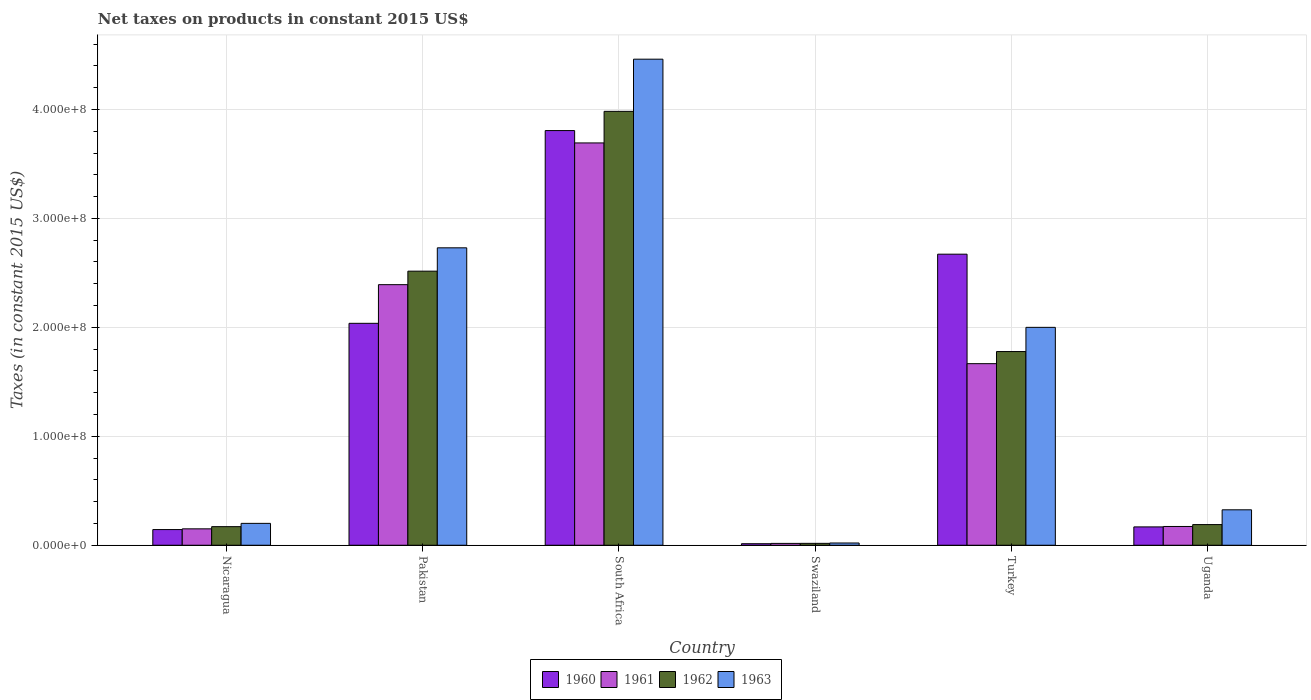How many different coloured bars are there?
Your answer should be compact. 4. How many groups of bars are there?
Your response must be concise. 6. Are the number of bars per tick equal to the number of legend labels?
Give a very brief answer. Yes. Are the number of bars on each tick of the X-axis equal?
Your response must be concise. Yes. What is the label of the 1st group of bars from the left?
Keep it short and to the point. Nicaragua. What is the net taxes on products in 1962 in Swaziland?
Make the answer very short. 1.73e+06. Across all countries, what is the maximum net taxes on products in 1960?
Offer a very short reply. 3.81e+08. Across all countries, what is the minimum net taxes on products in 1961?
Offer a very short reply. 1.69e+06. In which country was the net taxes on products in 1962 maximum?
Give a very brief answer. South Africa. In which country was the net taxes on products in 1962 minimum?
Offer a very short reply. Swaziland. What is the total net taxes on products in 1962 in the graph?
Make the answer very short. 8.65e+08. What is the difference between the net taxes on products in 1961 in Swaziland and that in Uganda?
Your answer should be very brief. -1.55e+07. What is the difference between the net taxes on products in 1960 in Swaziland and the net taxes on products in 1961 in Uganda?
Offer a terse response. -1.58e+07. What is the average net taxes on products in 1960 per country?
Your answer should be compact. 1.47e+08. What is the difference between the net taxes on products of/in 1961 and net taxes on products of/in 1963 in Uganda?
Make the answer very short. -1.53e+07. In how many countries, is the net taxes on products in 1963 greater than 40000000 US$?
Provide a succinct answer. 3. What is the ratio of the net taxes on products in 1962 in South Africa to that in Turkey?
Provide a succinct answer. 2.24. Is the net taxes on products in 1963 in South Africa less than that in Uganda?
Give a very brief answer. No. What is the difference between the highest and the second highest net taxes on products in 1962?
Offer a terse response. 2.20e+08. What is the difference between the highest and the lowest net taxes on products in 1963?
Provide a short and direct response. 4.44e+08. Is the sum of the net taxes on products in 1963 in Turkey and Uganda greater than the maximum net taxes on products in 1962 across all countries?
Offer a terse response. No. What does the 2nd bar from the left in Turkey represents?
Keep it short and to the point. 1961. What is the difference between two consecutive major ticks on the Y-axis?
Your answer should be very brief. 1.00e+08. Does the graph contain any zero values?
Ensure brevity in your answer.  No. Where does the legend appear in the graph?
Your response must be concise. Bottom center. How many legend labels are there?
Provide a short and direct response. 4. How are the legend labels stacked?
Keep it short and to the point. Horizontal. What is the title of the graph?
Your answer should be compact. Net taxes on products in constant 2015 US$. What is the label or title of the X-axis?
Offer a very short reply. Country. What is the label or title of the Y-axis?
Give a very brief answer. Taxes (in constant 2015 US$). What is the Taxes (in constant 2015 US$) of 1960 in Nicaragua?
Ensure brevity in your answer.  1.44e+07. What is the Taxes (in constant 2015 US$) of 1961 in Nicaragua?
Offer a very short reply. 1.51e+07. What is the Taxes (in constant 2015 US$) of 1962 in Nicaragua?
Make the answer very short. 1.71e+07. What is the Taxes (in constant 2015 US$) of 1963 in Nicaragua?
Provide a succinct answer. 2.01e+07. What is the Taxes (in constant 2015 US$) of 1960 in Pakistan?
Provide a short and direct response. 2.04e+08. What is the Taxes (in constant 2015 US$) of 1961 in Pakistan?
Ensure brevity in your answer.  2.39e+08. What is the Taxes (in constant 2015 US$) of 1962 in Pakistan?
Ensure brevity in your answer.  2.52e+08. What is the Taxes (in constant 2015 US$) in 1963 in Pakistan?
Provide a succinct answer. 2.73e+08. What is the Taxes (in constant 2015 US$) of 1960 in South Africa?
Offer a very short reply. 3.81e+08. What is the Taxes (in constant 2015 US$) of 1961 in South Africa?
Offer a terse response. 3.69e+08. What is the Taxes (in constant 2015 US$) in 1962 in South Africa?
Keep it short and to the point. 3.98e+08. What is the Taxes (in constant 2015 US$) of 1963 in South Africa?
Your answer should be very brief. 4.46e+08. What is the Taxes (in constant 2015 US$) of 1960 in Swaziland?
Your answer should be very brief. 1.40e+06. What is the Taxes (in constant 2015 US$) in 1961 in Swaziland?
Ensure brevity in your answer.  1.69e+06. What is the Taxes (in constant 2015 US$) in 1962 in Swaziland?
Your answer should be very brief. 1.73e+06. What is the Taxes (in constant 2015 US$) in 1963 in Swaziland?
Your answer should be compact. 2.06e+06. What is the Taxes (in constant 2015 US$) in 1960 in Turkey?
Keep it short and to the point. 2.67e+08. What is the Taxes (in constant 2015 US$) of 1961 in Turkey?
Offer a terse response. 1.67e+08. What is the Taxes (in constant 2015 US$) of 1962 in Turkey?
Make the answer very short. 1.78e+08. What is the Taxes (in constant 2015 US$) of 1960 in Uganda?
Your answer should be very brief. 1.68e+07. What is the Taxes (in constant 2015 US$) of 1961 in Uganda?
Offer a terse response. 1.72e+07. What is the Taxes (in constant 2015 US$) in 1962 in Uganda?
Your answer should be compact. 1.90e+07. What is the Taxes (in constant 2015 US$) of 1963 in Uganda?
Make the answer very short. 3.25e+07. Across all countries, what is the maximum Taxes (in constant 2015 US$) in 1960?
Your answer should be very brief. 3.81e+08. Across all countries, what is the maximum Taxes (in constant 2015 US$) in 1961?
Keep it short and to the point. 3.69e+08. Across all countries, what is the maximum Taxes (in constant 2015 US$) in 1962?
Keep it short and to the point. 3.98e+08. Across all countries, what is the maximum Taxes (in constant 2015 US$) of 1963?
Provide a short and direct response. 4.46e+08. Across all countries, what is the minimum Taxes (in constant 2015 US$) in 1960?
Provide a succinct answer. 1.40e+06. Across all countries, what is the minimum Taxes (in constant 2015 US$) in 1961?
Provide a short and direct response. 1.69e+06. Across all countries, what is the minimum Taxes (in constant 2015 US$) in 1962?
Provide a succinct answer. 1.73e+06. Across all countries, what is the minimum Taxes (in constant 2015 US$) of 1963?
Keep it short and to the point. 2.06e+06. What is the total Taxes (in constant 2015 US$) of 1960 in the graph?
Offer a very short reply. 8.84e+08. What is the total Taxes (in constant 2015 US$) of 1961 in the graph?
Your answer should be very brief. 8.09e+08. What is the total Taxes (in constant 2015 US$) in 1962 in the graph?
Offer a very short reply. 8.65e+08. What is the total Taxes (in constant 2015 US$) of 1963 in the graph?
Offer a terse response. 9.74e+08. What is the difference between the Taxes (in constant 2015 US$) of 1960 in Nicaragua and that in Pakistan?
Your answer should be compact. -1.89e+08. What is the difference between the Taxes (in constant 2015 US$) in 1961 in Nicaragua and that in Pakistan?
Keep it short and to the point. -2.24e+08. What is the difference between the Taxes (in constant 2015 US$) of 1962 in Nicaragua and that in Pakistan?
Provide a succinct answer. -2.35e+08. What is the difference between the Taxes (in constant 2015 US$) in 1963 in Nicaragua and that in Pakistan?
Provide a succinct answer. -2.53e+08. What is the difference between the Taxes (in constant 2015 US$) of 1960 in Nicaragua and that in South Africa?
Provide a short and direct response. -3.66e+08. What is the difference between the Taxes (in constant 2015 US$) in 1961 in Nicaragua and that in South Africa?
Keep it short and to the point. -3.54e+08. What is the difference between the Taxes (in constant 2015 US$) in 1962 in Nicaragua and that in South Africa?
Your answer should be very brief. -3.81e+08. What is the difference between the Taxes (in constant 2015 US$) in 1963 in Nicaragua and that in South Africa?
Keep it short and to the point. -4.26e+08. What is the difference between the Taxes (in constant 2015 US$) in 1960 in Nicaragua and that in Swaziland?
Make the answer very short. 1.30e+07. What is the difference between the Taxes (in constant 2015 US$) of 1961 in Nicaragua and that in Swaziland?
Offer a terse response. 1.34e+07. What is the difference between the Taxes (in constant 2015 US$) in 1962 in Nicaragua and that in Swaziland?
Provide a succinct answer. 1.53e+07. What is the difference between the Taxes (in constant 2015 US$) of 1963 in Nicaragua and that in Swaziland?
Give a very brief answer. 1.80e+07. What is the difference between the Taxes (in constant 2015 US$) of 1960 in Nicaragua and that in Turkey?
Offer a terse response. -2.53e+08. What is the difference between the Taxes (in constant 2015 US$) of 1961 in Nicaragua and that in Turkey?
Your response must be concise. -1.52e+08. What is the difference between the Taxes (in constant 2015 US$) of 1962 in Nicaragua and that in Turkey?
Your response must be concise. -1.61e+08. What is the difference between the Taxes (in constant 2015 US$) of 1963 in Nicaragua and that in Turkey?
Keep it short and to the point. -1.80e+08. What is the difference between the Taxes (in constant 2015 US$) of 1960 in Nicaragua and that in Uganda?
Make the answer very short. -2.45e+06. What is the difference between the Taxes (in constant 2015 US$) of 1961 in Nicaragua and that in Uganda?
Make the answer very short. -2.17e+06. What is the difference between the Taxes (in constant 2015 US$) of 1962 in Nicaragua and that in Uganda?
Your answer should be very brief. -1.89e+06. What is the difference between the Taxes (in constant 2015 US$) in 1963 in Nicaragua and that in Uganda?
Provide a short and direct response. -1.24e+07. What is the difference between the Taxes (in constant 2015 US$) of 1960 in Pakistan and that in South Africa?
Your response must be concise. -1.77e+08. What is the difference between the Taxes (in constant 2015 US$) of 1961 in Pakistan and that in South Africa?
Ensure brevity in your answer.  -1.30e+08. What is the difference between the Taxes (in constant 2015 US$) of 1962 in Pakistan and that in South Africa?
Your answer should be very brief. -1.47e+08. What is the difference between the Taxes (in constant 2015 US$) in 1963 in Pakistan and that in South Africa?
Offer a terse response. -1.73e+08. What is the difference between the Taxes (in constant 2015 US$) of 1960 in Pakistan and that in Swaziland?
Your answer should be compact. 2.02e+08. What is the difference between the Taxes (in constant 2015 US$) of 1961 in Pakistan and that in Swaziland?
Make the answer very short. 2.37e+08. What is the difference between the Taxes (in constant 2015 US$) in 1962 in Pakistan and that in Swaziland?
Your response must be concise. 2.50e+08. What is the difference between the Taxes (in constant 2015 US$) in 1963 in Pakistan and that in Swaziland?
Provide a short and direct response. 2.71e+08. What is the difference between the Taxes (in constant 2015 US$) in 1960 in Pakistan and that in Turkey?
Provide a short and direct response. -6.35e+07. What is the difference between the Taxes (in constant 2015 US$) in 1961 in Pakistan and that in Turkey?
Keep it short and to the point. 7.25e+07. What is the difference between the Taxes (in constant 2015 US$) in 1962 in Pakistan and that in Turkey?
Your answer should be very brief. 7.38e+07. What is the difference between the Taxes (in constant 2015 US$) in 1963 in Pakistan and that in Turkey?
Your response must be concise. 7.30e+07. What is the difference between the Taxes (in constant 2015 US$) in 1960 in Pakistan and that in Uganda?
Make the answer very short. 1.87e+08. What is the difference between the Taxes (in constant 2015 US$) of 1961 in Pakistan and that in Uganda?
Ensure brevity in your answer.  2.22e+08. What is the difference between the Taxes (in constant 2015 US$) of 1962 in Pakistan and that in Uganda?
Offer a terse response. 2.33e+08. What is the difference between the Taxes (in constant 2015 US$) in 1963 in Pakistan and that in Uganda?
Your answer should be very brief. 2.40e+08. What is the difference between the Taxes (in constant 2015 US$) of 1960 in South Africa and that in Swaziland?
Make the answer very short. 3.79e+08. What is the difference between the Taxes (in constant 2015 US$) in 1961 in South Africa and that in Swaziland?
Give a very brief answer. 3.68e+08. What is the difference between the Taxes (in constant 2015 US$) in 1962 in South Africa and that in Swaziland?
Provide a succinct answer. 3.97e+08. What is the difference between the Taxes (in constant 2015 US$) of 1963 in South Africa and that in Swaziland?
Provide a succinct answer. 4.44e+08. What is the difference between the Taxes (in constant 2015 US$) in 1960 in South Africa and that in Turkey?
Keep it short and to the point. 1.13e+08. What is the difference between the Taxes (in constant 2015 US$) of 1961 in South Africa and that in Turkey?
Provide a short and direct response. 2.03e+08. What is the difference between the Taxes (in constant 2015 US$) of 1962 in South Africa and that in Turkey?
Your response must be concise. 2.20e+08. What is the difference between the Taxes (in constant 2015 US$) in 1963 in South Africa and that in Turkey?
Keep it short and to the point. 2.46e+08. What is the difference between the Taxes (in constant 2015 US$) in 1960 in South Africa and that in Uganda?
Make the answer very short. 3.64e+08. What is the difference between the Taxes (in constant 2015 US$) in 1961 in South Africa and that in Uganda?
Offer a very short reply. 3.52e+08. What is the difference between the Taxes (in constant 2015 US$) in 1962 in South Africa and that in Uganda?
Give a very brief answer. 3.79e+08. What is the difference between the Taxes (in constant 2015 US$) of 1963 in South Africa and that in Uganda?
Provide a short and direct response. 4.14e+08. What is the difference between the Taxes (in constant 2015 US$) of 1960 in Swaziland and that in Turkey?
Your answer should be compact. -2.66e+08. What is the difference between the Taxes (in constant 2015 US$) of 1961 in Swaziland and that in Turkey?
Your response must be concise. -1.65e+08. What is the difference between the Taxes (in constant 2015 US$) in 1962 in Swaziland and that in Turkey?
Offer a very short reply. -1.76e+08. What is the difference between the Taxes (in constant 2015 US$) of 1963 in Swaziland and that in Turkey?
Make the answer very short. -1.98e+08. What is the difference between the Taxes (in constant 2015 US$) of 1960 in Swaziland and that in Uganda?
Make the answer very short. -1.54e+07. What is the difference between the Taxes (in constant 2015 US$) in 1961 in Swaziland and that in Uganda?
Offer a very short reply. -1.55e+07. What is the difference between the Taxes (in constant 2015 US$) in 1962 in Swaziland and that in Uganda?
Keep it short and to the point. -1.72e+07. What is the difference between the Taxes (in constant 2015 US$) of 1963 in Swaziland and that in Uganda?
Your response must be concise. -3.05e+07. What is the difference between the Taxes (in constant 2015 US$) in 1960 in Turkey and that in Uganda?
Keep it short and to the point. 2.50e+08. What is the difference between the Taxes (in constant 2015 US$) of 1961 in Turkey and that in Uganda?
Offer a terse response. 1.49e+08. What is the difference between the Taxes (in constant 2015 US$) in 1962 in Turkey and that in Uganda?
Offer a terse response. 1.59e+08. What is the difference between the Taxes (in constant 2015 US$) in 1963 in Turkey and that in Uganda?
Provide a succinct answer. 1.67e+08. What is the difference between the Taxes (in constant 2015 US$) in 1960 in Nicaragua and the Taxes (in constant 2015 US$) in 1961 in Pakistan?
Keep it short and to the point. -2.25e+08. What is the difference between the Taxes (in constant 2015 US$) in 1960 in Nicaragua and the Taxes (in constant 2015 US$) in 1962 in Pakistan?
Make the answer very short. -2.37e+08. What is the difference between the Taxes (in constant 2015 US$) in 1960 in Nicaragua and the Taxes (in constant 2015 US$) in 1963 in Pakistan?
Your response must be concise. -2.59e+08. What is the difference between the Taxes (in constant 2015 US$) of 1961 in Nicaragua and the Taxes (in constant 2015 US$) of 1962 in Pakistan?
Keep it short and to the point. -2.37e+08. What is the difference between the Taxes (in constant 2015 US$) of 1961 in Nicaragua and the Taxes (in constant 2015 US$) of 1963 in Pakistan?
Your response must be concise. -2.58e+08. What is the difference between the Taxes (in constant 2015 US$) in 1962 in Nicaragua and the Taxes (in constant 2015 US$) in 1963 in Pakistan?
Ensure brevity in your answer.  -2.56e+08. What is the difference between the Taxes (in constant 2015 US$) in 1960 in Nicaragua and the Taxes (in constant 2015 US$) in 1961 in South Africa?
Make the answer very short. -3.55e+08. What is the difference between the Taxes (in constant 2015 US$) in 1960 in Nicaragua and the Taxes (in constant 2015 US$) in 1962 in South Africa?
Make the answer very short. -3.84e+08. What is the difference between the Taxes (in constant 2015 US$) of 1960 in Nicaragua and the Taxes (in constant 2015 US$) of 1963 in South Africa?
Provide a succinct answer. -4.32e+08. What is the difference between the Taxes (in constant 2015 US$) in 1961 in Nicaragua and the Taxes (in constant 2015 US$) in 1962 in South Africa?
Ensure brevity in your answer.  -3.83e+08. What is the difference between the Taxes (in constant 2015 US$) of 1961 in Nicaragua and the Taxes (in constant 2015 US$) of 1963 in South Africa?
Offer a terse response. -4.31e+08. What is the difference between the Taxes (in constant 2015 US$) in 1962 in Nicaragua and the Taxes (in constant 2015 US$) in 1963 in South Africa?
Make the answer very short. -4.29e+08. What is the difference between the Taxes (in constant 2015 US$) in 1960 in Nicaragua and the Taxes (in constant 2015 US$) in 1961 in Swaziland?
Offer a terse response. 1.27e+07. What is the difference between the Taxes (in constant 2015 US$) in 1960 in Nicaragua and the Taxes (in constant 2015 US$) in 1962 in Swaziland?
Provide a succinct answer. 1.27e+07. What is the difference between the Taxes (in constant 2015 US$) in 1960 in Nicaragua and the Taxes (in constant 2015 US$) in 1963 in Swaziland?
Your answer should be very brief. 1.23e+07. What is the difference between the Taxes (in constant 2015 US$) in 1961 in Nicaragua and the Taxes (in constant 2015 US$) in 1962 in Swaziland?
Provide a short and direct response. 1.33e+07. What is the difference between the Taxes (in constant 2015 US$) of 1961 in Nicaragua and the Taxes (in constant 2015 US$) of 1963 in Swaziland?
Offer a very short reply. 1.30e+07. What is the difference between the Taxes (in constant 2015 US$) of 1962 in Nicaragua and the Taxes (in constant 2015 US$) of 1963 in Swaziland?
Offer a very short reply. 1.50e+07. What is the difference between the Taxes (in constant 2015 US$) in 1960 in Nicaragua and the Taxes (in constant 2015 US$) in 1961 in Turkey?
Offer a terse response. -1.52e+08. What is the difference between the Taxes (in constant 2015 US$) of 1960 in Nicaragua and the Taxes (in constant 2015 US$) of 1962 in Turkey?
Keep it short and to the point. -1.63e+08. What is the difference between the Taxes (in constant 2015 US$) of 1960 in Nicaragua and the Taxes (in constant 2015 US$) of 1963 in Turkey?
Keep it short and to the point. -1.86e+08. What is the difference between the Taxes (in constant 2015 US$) in 1961 in Nicaragua and the Taxes (in constant 2015 US$) in 1962 in Turkey?
Give a very brief answer. -1.63e+08. What is the difference between the Taxes (in constant 2015 US$) in 1961 in Nicaragua and the Taxes (in constant 2015 US$) in 1963 in Turkey?
Your response must be concise. -1.85e+08. What is the difference between the Taxes (in constant 2015 US$) of 1962 in Nicaragua and the Taxes (in constant 2015 US$) of 1963 in Turkey?
Your answer should be compact. -1.83e+08. What is the difference between the Taxes (in constant 2015 US$) of 1960 in Nicaragua and the Taxes (in constant 2015 US$) of 1961 in Uganda?
Your response must be concise. -2.84e+06. What is the difference between the Taxes (in constant 2015 US$) in 1960 in Nicaragua and the Taxes (in constant 2015 US$) in 1962 in Uganda?
Ensure brevity in your answer.  -4.57e+06. What is the difference between the Taxes (in constant 2015 US$) of 1960 in Nicaragua and the Taxes (in constant 2015 US$) of 1963 in Uganda?
Ensure brevity in your answer.  -1.81e+07. What is the difference between the Taxes (in constant 2015 US$) in 1961 in Nicaragua and the Taxes (in constant 2015 US$) in 1962 in Uganda?
Make the answer very short. -3.90e+06. What is the difference between the Taxes (in constant 2015 US$) of 1961 in Nicaragua and the Taxes (in constant 2015 US$) of 1963 in Uganda?
Ensure brevity in your answer.  -1.75e+07. What is the difference between the Taxes (in constant 2015 US$) in 1962 in Nicaragua and the Taxes (in constant 2015 US$) in 1963 in Uganda?
Your answer should be compact. -1.55e+07. What is the difference between the Taxes (in constant 2015 US$) in 1960 in Pakistan and the Taxes (in constant 2015 US$) in 1961 in South Africa?
Provide a short and direct response. -1.66e+08. What is the difference between the Taxes (in constant 2015 US$) of 1960 in Pakistan and the Taxes (in constant 2015 US$) of 1962 in South Africa?
Provide a short and direct response. -1.95e+08. What is the difference between the Taxes (in constant 2015 US$) in 1960 in Pakistan and the Taxes (in constant 2015 US$) in 1963 in South Africa?
Give a very brief answer. -2.42e+08. What is the difference between the Taxes (in constant 2015 US$) in 1961 in Pakistan and the Taxes (in constant 2015 US$) in 1962 in South Africa?
Ensure brevity in your answer.  -1.59e+08. What is the difference between the Taxes (in constant 2015 US$) in 1961 in Pakistan and the Taxes (in constant 2015 US$) in 1963 in South Africa?
Provide a succinct answer. -2.07e+08. What is the difference between the Taxes (in constant 2015 US$) of 1962 in Pakistan and the Taxes (in constant 2015 US$) of 1963 in South Africa?
Your answer should be compact. -1.95e+08. What is the difference between the Taxes (in constant 2015 US$) in 1960 in Pakistan and the Taxes (in constant 2015 US$) in 1961 in Swaziland?
Make the answer very short. 2.02e+08. What is the difference between the Taxes (in constant 2015 US$) of 1960 in Pakistan and the Taxes (in constant 2015 US$) of 1962 in Swaziland?
Offer a very short reply. 2.02e+08. What is the difference between the Taxes (in constant 2015 US$) in 1960 in Pakistan and the Taxes (in constant 2015 US$) in 1963 in Swaziland?
Make the answer very short. 2.02e+08. What is the difference between the Taxes (in constant 2015 US$) in 1961 in Pakistan and the Taxes (in constant 2015 US$) in 1962 in Swaziland?
Make the answer very short. 2.37e+08. What is the difference between the Taxes (in constant 2015 US$) of 1961 in Pakistan and the Taxes (in constant 2015 US$) of 1963 in Swaziland?
Ensure brevity in your answer.  2.37e+08. What is the difference between the Taxes (in constant 2015 US$) in 1962 in Pakistan and the Taxes (in constant 2015 US$) in 1963 in Swaziland?
Ensure brevity in your answer.  2.50e+08. What is the difference between the Taxes (in constant 2015 US$) in 1960 in Pakistan and the Taxes (in constant 2015 US$) in 1961 in Turkey?
Ensure brevity in your answer.  3.70e+07. What is the difference between the Taxes (in constant 2015 US$) in 1960 in Pakistan and the Taxes (in constant 2015 US$) in 1962 in Turkey?
Provide a succinct answer. 2.59e+07. What is the difference between the Taxes (in constant 2015 US$) of 1960 in Pakistan and the Taxes (in constant 2015 US$) of 1963 in Turkey?
Give a very brief answer. 3.70e+06. What is the difference between the Taxes (in constant 2015 US$) of 1961 in Pakistan and the Taxes (in constant 2015 US$) of 1962 in Turkey?
Your response must be concise. 6.14e+07. What is the difference between the Taxes (in constant 2015 US$) of 1961 in Pakistan and the Taxes (in constant 2015 US$) of 1963 in Turkey?
Your answer should be compact. 3.92e+07. What is the difference between the Taxes (in constant 2015 US$) in 1962 in Pakistan and the Taxes (in constant 2015 US$) in 1963 in Turkey?
Your response must be concise. 5.16e+07. What is the difference between the Taxes (in constant 2015 US$) of 1960 in Pakistan and the Taxes (in constant 2015 US$) of 1961 in Uganda?
Provide a succinct answer. 1.86e+08. What is the difference between the Taxes (in constant 2015 US$) in 1960 in Pakistan and the Taxes (in constant 2015 US$) in 1962 in Uganda?
Keep it short and to the point. 1.85e+08. What is the difference between the Taxes (in constant 2015 US$) in 1960 in Pakistan and the Taxes (in constant 2015 US$) in 1963 in Uganda?
Make the answer very short. 1.71e+08. What is the difference between the Taxes (in constant 2015 US$) in 1961 in Pakistan and the Taxes (in constant 2015 US$) in 1962 in Uganda?
Provide a succinct answer. 2.20e+08. What is the difference between the Taxes (in constant 2015 US$) in 1961 in Pakistan and the Taxes (in constant 2015 US$) in 1963 in Uganda?
Offer a terse response. 2.07e+08. What is the difference between the Taxes (in constant 2015 US$) of 1962 in Pakistan and the Taxes (in constant 2015 US$) of 1963 in Uganda?
Keep it short and to the point. 2.19e+08. What is the difference between the Taxes (in constant 2015 US$) in 1960 in South Africa and the Taxes (in constant 2015 US$) in 1961 in Swaziland?
Ensure brevity in your answer.  3.79e+08. What is the difference between the Taxes (in constant 2015 US$) in 1960 in South Africa and the Taxes (in constant 2015 US$) in 1962 in Swaziland?
Keep it short and to the point. 3.79e+08. What is the difference between the Taxes (in constant 2015 US$) in 1960 in South Africa and the Taxes (in constant 2015 US$) in 1963 in Swaziland?
Ensure brevity in your answer.  3.79e+08. What is the difference between the Taxes (in constant 2015 US$) in 1961 in South Africa and the Taxes (in constant 2015 US$) in 1962 in Swaziland?
Keep it short and to the point. 3.68e+08. What is the difference between the Taxes (in constant 2015 US$) of 1961 in South Africa and the Taxes (in constant 2015 US$) of 1963 in Swaziland?
Offer a very short reply. 3.67e+08. What is the difference between the Taxes (in constant 2015 US$) in 1962 in South Africa and the Taxes (in constant 2015 US$) in 1963 in Swaziland?
Provide a succinct answer. 3.96e+08. What is the difference between the Taxes (in constant 2015 US$) in 1960 in South Africa and the Taxes (in constant 2015 US$) in 1961 in Turkey?
Offer a terse response. 2.14e+08. What is the difference between the Taxes (in constant 2015 US$) of 1960 in South Africa and the Taxes (in constant 2015 US$) of 1962 in Turkey?
Ensure brevity in your answer.  2.03e+08. What is the difference between the Taxes (in constant 2015 US$) in 1960 in South Africa and the Taxes (in constant 2015 US$) in 1963 in Turkey?
Give a very brief answer. 1.81e+08. What is the difference between the Taxes (in constant 2015 US$) of 1961 in South Africa and the Taxes (in constant 2015 US$) of 1962 in Turkey?
Keep it short and to the point. 1.91e+08. What is the difference between the Taxes (in constant 2015 US$) of 1961 in South Africa and the Taxes (in constant 2015 US$) of 1963 in Turkey?
Offer a very short reply. 1.69e+08. What is the difference between the Taxes (in constant 2015 US$) in 1962 in South Africa and the Taxes (in constant 2015 US$) in 1963 in Turkey?
Offer a very short reply. 1.98e+08. What is the difference between the Taxes (in constant 2015 US$) in 1960 in South Africa and the Taxes (in constant 2015 US$) in 1961 in Uganda?
Your answer should be compact. 3.63e+08. What is the difference between the Taxes (in constant 2015 US$) of 1960 in South Africa and the Taxes (in constant 2015 US$) of 1962 in Uganda?
Give a very brief answer. 3.62e+08. What is the difference between the Taxes (in constant 2015 US$) of 1960 in South Africa and the Taxes (in constant 2015 US$) of 1963 in Uganda?
Make the answer very short. 3.48e+08. What is the difference between the Taxes (in constant 2015 US$) of 1961 in South Africa and the Taxes (in constant 2015 US$) of 1962 in Uganda?
Your response must be concise. 3.50e+08. What is the difference between the Taxes (in constant 2015 US$) in 1961 in South Africa and the Taxes (in constant 2015 US$) in 1963 in Uganda?
Provide a short and direct response. 3.37e+08. What is the difference between the Taxes (in constant 2015 US$) in 1962 in South Africa and the Taxes (in constant 2015 US$) in 1963 in Uganda?
Make the answer very short. 3.66e+08. What is the difference between the Taxes (in constant 2015 US$) in 1960 in Swaziland and the Taxes (in constant 2015 US$) in 1961 in Turkey?
Your answer should be compact. -1.65e+08. What is the difference between the Taxes (in constant 2015 US$) of 1960 in Swaziland and the Taxes (in constant 2015 US$) of 1962 in Turkey?
Give a very brief answer. -1.76e+08. What is the difference between the Taxes (in constant 2015 US$) of 1960 in Swaziland and the Taxes (in constant 2015 US$) of 1963 in Turkey?
Provide a short and direct response. -1.99e+08. What is the difference between the Taxes (in constant 2015 US$) in 1961 in Swaziland and the Taxes (in constant 2015 US$) in 1962 in Turkey?
Make the answer very short. -1.76e+08. What is the difference between the Taxes (in constant 2015 US$) in 1961 in Swaziland and the Taxes (in constant 2015 US$) in 1963 in Turkey?
Offer a terse response. -1.98e+08. What is the difference between the Taxes (in constant 2015 US$) in 1962 in Swaziland and the Taxes (in constant 2015 US$) in 1963 in Turkey?
Keep it short and to the point. -1.98e+08. What is the difference between the Taxes (in constant 2015 US$) of 1960 in Swaziland and the Taxes (in constant 2015 US$) of 1961 in Uganda?
Ensure brevity in your answer.  -1.58e+07. What is the difference between the Taxes (in constant 2015 US$) of 1960 in Swaziland and the Taxes (in constant 2015 US$) of 1962 in Uganda?
Make the answer very short. -1.76e+07. What is the difference between the Taxes (in constant 2015 US$) of 1960 in Swaziland and the Taxes (in constant 2015 US$) of 1963 in Uganda?
Give a very brief answer. -3.11e+07. What is the difference between the Taxes (in constant 2015 US$) of 1961 in Swaziland and the Taxes (in constant 2015 US$) of 1962 in Uganda?
Ensure brevity in your answer.  -1.73e+07. What is the difference between the Taxes (in constant 2015 US$) of 1961 in Swaziland and the Taxes (in constant 2015 US$) of 1963 in Uganda?
Make the answer very short. -3.08e+07. What is the difference between the Taxes (in constant 2015 US$) in 1962 in Swaziland and the Taxes (in constant 2015 US$) in 1963 in Uganda?
Your response must be concise. -3.08e+07. What is the difference between the Taxes (in constant 2015 US$) of 1960 in Turkey and the Taxes (in constant 2015 US$) of 1961 in Uganda?
Offer a very short reply. 2.50e+08. What is the difference between the Taxes (in constant 2015 US$) of 1960 in Turkey and the Taxes (in constant 2015 US$) of 1962 in Uganda?
Make the answer very short. 2.48e+08. What is the difference between the Taxes (in constant 2015 US$) of 1960 in Turkey and the Taxes (in constant 2015 US$) of 1963 in Uganda?
Give a very brief answer. 2.35e+08. What is the difference between the Taxes (in constant 2015 US$) in 1961 in Turkey and the Taxes (in constant 2015 US$) in 1962 in Uganda?
Your response must be concise. 1.48e+08. What is the difference between the Taxes (in constant 2015 US$) of 1961 in Turkey and the Taxes (in constant 2015 US$) of 1963 in Uganda?
Your answer should be compact. 1.34e+08. What is the difference between the Taxes (in constant 2015 US$) of 1962 in Turkey and the Taxes (in constant 2015 US$) of 1963 in Uganda?
Your answer should be compact. 1.45e+08. What is the average Taxes (in constant 2015 US$) in 1960 per country?
Your answer should be very brief. 1.47e+08. What is the average Taxes (in constant 2015 US$) of 1961 per country?
Offer a very short reply. 1.35e+08. What is the average Taxes (in constant 2015 US$) in 1962 per country?
Give a very brief answer. 1.44e+08. What is the average Taxes (in constant 2015 US$) of 1963 per country?
Keep it short and to the point. 1.62e+08. What is the difference between the Taxes (in constant 2015 US$) of 1960 and Taxes (in constant 2015 US$) of 1961 in Nicaragua?
Make the answer very short. -6.69e+05. What is the difference between the Taxes (in constant 2015 US$) of 1960 and Taxes (in constant 2015 US$) of 1962 in Nicaragua?
Your answer should be very brief. -2.68e+06. What is the difference between the Taxes (in constant 2015 US$) in 1960 and Taxes (in constant 2015 US$) in 1963 in Nicaragua?
Give a very brief answer. -5.69e+06. What is the difference between the Taxes (in constant 2015 US$) of 1961 and Taxes (in constant 2015 US$) of 1962 in Nicaragua?
Your response must be concise. -2.01e+06. What is the difference between the Taxes (in constant 2015 US$) in 1961 and Taxes (in constant 2015 US$) in 1963 in Nicaragua?
Make the answer very short. -5.02e+06. What is the difference between the Taxes (in constant 2015 US$) of 1962 and Taxes (in constant 2015 US$) of 1963 in Nicaragua?
Offer a terse response. -3.01e+06. What is the difference between the Taxes (in constant 2015 US$) of 1960 and Taxes (in constant 2015 US$) of 1961 in Pakistan?
Provide a succinct answer. -3.55e+07. What is the difference between the Taxes (in constant 2015 US$) in 1960 and Taxes (in constant 2015 US$) in 1962 in Pakistan?
Give a very brief answer. -4.79e+07. What is the difference between the Taxes (in constant 2015 US$) in 1960 and Taxes (in constant 2015 US$) in 1963 in Pakistan?
Ensure brevity in your answer.  -6.93e+07. What is the difference between the Taxes (in constant 2015 US$) of 1961 and Taxes (in constant 2015 US$) of 1962 in Pakistan?
Keep it short and to the point. -1.24e+07. What is the difference between the Taxes (in constant 2015 US$) in 1961 and Taxes (in constant 2015 US$) in 1963 in Pakistan?
Provide a succinct answer. -3.38e+07. What is the difference between the Taxes (in constant 2015 US$) in 1962 and Taxes (in constant 2015 US$) in 1963 in Pakistan?
Make the answer very short. -2.14e+07. What is the difference between the Taxes (in constant 2015 US$) of 1960 and Taxes (in constant 2015 US$) of 1961 in South Africa?
Your answer should be very brief. 1.13e+07. What is the difference between the Taxes (in constant 2015 US$) of 1960 and Taxes (in constant 2015 US$) of 1962 in South Africa?
Offer a terse response. -1.76e+07. What is the difference between the Taxes (in constant 2015 US$) of 1960 and Taxes (in constant 2015 US$) of 1963 in South Africa?
Your response must be concise. -6.55e+07. What is the difference between the Taxes (in constant 2015 US$) in 1961 and Taxes (in constant 2015 US$) in 1962 in South Africa?
Your answer should be very brief. -2.90e+07. What is the difference between the Taxes (in constant 2015 US$) in 1961 and Taxes (in constant 2015 US$) in 1963 in South Africa?
Make the answer very short. -7.69e+07. What is the difference between the Taxes (in constant 2015 US$) of 1962 and Taxes (in constant 2015 US$) of 1963 in South Africa?
Offer a terse response. -4.79e+07. What is the difference between the Taxes (in constant 2015 US$) of 1960 and Taxes (in constant 2015 US$) of 1961 in Swaziland?
Offer a very short reply. -2.89e+05. What is the difference between the Taxes (in constant 2015 US$) in 1960 and Taxes (in constant 2015 US$) in 1962 in Swaziland?
Offer a very short reply. -3.30e+05. What is the difference between the Taxes (in constant 2015 US$) of 1960 and Taxes (in constant 2015 US$) of 1963 in Swaziland?
Offer a very short reply. -6.61e+05. What is the difference between the Taxes (in constant 2015 US$) in 1961 and Taxes (in constant 2015 US$) in 1962 in Swaziland?
Provide a succinct answer. -4.13e+04. What is the difference between the Taxes (in constant 2015 US$) of 1961 and Taxes (in constant 2015 US$) of 1963 in Swaziland?
Your response must be concise. -3.72e+05. What is the difference between the Taxes (in constant 2015 US$) in 1962 and Taxes (in constant 2015 US$) in 1963 in Swaziland?
Make the answer very short. -3.30e+05. What is the difference between the Taxes (in constant 2015 US$) in 1960 and Taxes (in constant 2015 US$) in 1961 in Turkey?
Provide a succinct answer. 1.00e+08. What is the difference between the Taxes (in constant 2015 US$) in 1960 and Taxes (in constant 2015 US$) in 1962 in Turkey?
Give a very brief answer. 8.94e+07. What is the difference between the Taxes (in constant 2015 US$) of 1960 and Taxes (in constant 2015 US$) of 1963 in Turkey?
Keep it short and to the point. 6.72e+07. What is the difference between the Taxes (in constant 2015 US$) in 1961 and Taxes (in constant 2015 US$) in 1962 in Turkey?
Give a very brief answer. -1.11e+07. What is the difference between the Taxes (in constant 2015 US$) of 1961 and Taxes (in constant 2015 US$) of 1963 in Turkey?
Your answer should be compact. -3.33e+07. What is the difference between the Taxes (in constant 2015 US$) of 1962 and Taxes (in constant 2015 US$) of 1963 in Turkey?
Give a very brief answer. -2.22e+07. What is the difference between the Taxes (in constant 2015 US$) of 1960 and Taxes (in constant 2015 US$) of 1961 in Uganda?
Ensure brevity in your answer.  -3.85e+05. What is the difference between the Taxes (in constant 2015 US$) of 1960 and Taxes (in constant 2015 US$) of 1962 in Uganda?
Your answer should be very brief. -2.12e+06. What is the difference between the Taxes (in constant 2015 US$) of 1960 and Taxes (in constant 2015 US$) of 1963 in Uganda?
Your response must be concise. -1.57e+07. What is the difference between the Taxes (in constant 2015 US$) in 1961 and Taxes (in constant 2015 US$) in 1962 in Uganda?
Offer a terse response. -1.73e+06. What is the difference between the Taxes (in constant 2015 US$) in 1961 and Taxes (in constant 2015 US$) in 1963 in Uganda?
Keep it short and to the point. -1.53e+07. What is the difference between the Taxes (in constant 2015 US$) in 1962 and Taxes (in constant 2015 US$) in 1963 in Uganda?
Give a very brief answer. -1.36e+07. What is the ratio of the Taxes (in constant 2015 US$) in 1960 in Nicaragua to that in Pakistan?
Offer a terse response. 0.07. What is the ratio of the Taxes (in constant 2015 US$) in 1961 in Nicaragua to that in Pakistan?
Provide a short and direct response. 0.06. What is the ratio of the Taxes (in constant 2015 US$) in 1962 in Nicaragua to that in Pakistan?
Offer a very short reply. 0.07. What is the ratio of the Taxes (in constant 2015 US$) in 1963 in Nicaragua to that in Pakistan?
Ensure brevity in your answer.  0.07. What is the ratio of the Taxes (in constant 2015 US$) of 1960 in Nicaragua to that in South Africa?
Keep it short and to the point. 0.04. What is the ratio of the Taxes (in constant 2015 US$) of 1961 in Nicaragua to that in South Africa?
Ensure brevity in your answer.  0.04. What is the ratio of the Taxes (in constant 2015 US$) of 1962 in Nicaragua to that in South Africa?
Make the answer very short. 0.04. What is the ratio of the Taxes (in constant 2015 US$) of 1963 in Nicaragua to that in South Africa?
Your answer should be compact. 0.04. What is the ratio of the Taxes (in constant 2015 US$) in 1960 in Nicaragua to that in Swaziland?
Your response must be concise. 10.25. What is the ratio of the Taxes (in constant 2015 US$) in 1961 in Nicaragua to that in Swaziland?
Your answer should be compact. 8.89. What is the ratio of the Taxes (in constant 2015 US$) in 1962 in Nicaragua to that in Swaziland?
Provide a short and direct response. 9.84. What is the ratio of the Taxes (in constant 2015 US$) in 1963 in Nicaragua to that in Swaziland?
Give a very brief answer. 9.73. What is the ratio of the Taxes (in constant 2015 US$) in 1960 in Nicaragua to that in Turkey?
Make the answer very short. 0.05. What is the ratio of the Taxes (in constant 2015 US$) in 1961 in Nicaragua to that in Turkey?
Give a very brief answer. 0.09. What is the ratio of the Taxes (in constant 2015 US$) in 1962 in Nicaragua to that in Turkey?
Ensure brevity in your answer.  0.1. What is the ratio of the Taxes (in constant 2015 US$) of 1963 in Nicaragua to that in Turkey?
Offer a terse response. 0.1. What is the ratio of the Taxes (in constant 2015 US$) of 1960 in Nicaragua to that in Uganda?
Offer a terse response. 0.85. What is the ratio of the Taxes (in constant 2015 US$) in 1961 in Nicaragua to that in Uganda?
Give a very brief answer. 0.87. What is the ratio of the Taxes (in constant 2015 US$) in 1962 in Nicaragua to that in Uganda?
Your response must be concise. 0.9. What is the ratio of the Taxes (in constant 2015 US$) of 1963 in Nicaragua to that in Uganda?
Make the answer very short. 0.62. What is the ratio of the Taxes (in constant 2015 US$) in 1960 in Pakistan to that in South Africa?
Your answer should be very brief. 0.54. What is the ratio of the Taxes (in constant 2015 US$) in 1961 in Pakistan to that in South Africa?
Give a very brief answer. 0.65. What is the ratio of the Taxes (in constant 2015 US$) in 1962 in Pakistan to that in South Africa?
Provide a short and direct response. 0.63. What is the ratio of the Taxes (in constant 2015 US$) of 1963 in Pakistan to that in South Africa?
Keep it short and to the point. 0.61. What is the ratio of the Taxes (in constant 2015 US$) in 1960 in Pakistan to that in Swaziland?
Ensure brevity in your answer.  145.12. What is the ratio of the Taxes (in constant 2015 US$) of 1961 in Pakistan to that in Swaziland?
Provide a short and direct response. 141.31. What is the ratio of the Taxes (in constant 2015 US$) of 1962 in Pakistan to that in Swaziland?
Make the answer very short. 145.09. What is the ratio of the Taxes (in constant 2015 US$) in 1963 in Pakistan to that in Swaziland?
Provide a short and direct response. 132.25. What is the ratio of the Taxes (in constant 2015 US$) of 1960 in Pakistan to that in Turkey?
Offer a terse response. 0.76. What is the ratio of the Taxes (in constant 2015 US$) of 1961 in Pakistan to that in Turkey?
Ensure brevity in your answer.  1.44. What is the ratio of the Taxes (in constant 2015 US$) in 1962 in Pakistan to that in Turkey?
Your response must be concise. 1.42. What is the ratio of the Taxes (in constant 2015 US$) in 1963 in Pakistan to that in Turkey?
Offer a very short reply. 1.36. What is the ratio of the Taxes (in constant 2015 US$) in 1960 in Pakistan to that in Uganda?
Offer a terse response. 12.1. What is the ratio of the Taxes (in constant 2015 US$) of 1961 in Pakistan to that in Uganda?
Offer a very short reply. 13.89. What is the ratio of the Taxes (in constant 2015 US$) of 1962 in Pakistan to that in Uganda?
Give a very brief answer. 13.27. What is the ratio of the Taxes (in constant 2015 US$) in 1963 in Pakistan to that in Uganda?
Your response must be concise. 8.39. What is the ratio of the Taxes (in constant 2015 US$) of 1960 in South Africa to that in Swaziland?
Ensure brevity in your answer.  271.17. What is the ratio of the Taxes (in constant 2015 US$) in 1961 in South Africa to that in Swaziland?
Provide a succinct answer. 218.17. What is the ratio of the Taxes (in constant 2015 US$) in 1962 in South Africa to that in Swaziland?
Your answer should be very brief. 229.69. What is the ratio of the Taxes (in constant 2015 US$) of 1963 in South Africa to that in Swaziland?
Ensure brevity in your answer.  216.15. What is the ratio of the Taxes (in constant 2015 US$) in 1960 in South Africa to that in Turkey?
Offer a terse response. 1.42. What is the ratio of the Taxes (in constant 2015 US$) of 1961 in South Africa to that in Turkey?
Offer a terse response. 2.22. What is the ratio of the Taxes (in constant 2015 US$) in 1962 in South Africa to that in Turkey?
Your answer should be compact. 2.24. What is the ratio of the Taxes (in constant 2015 US$) of 1963 in South Africa to that in Turkey?
Make the answer very short. 2.23. What is the ratio of the Taxes (in constant 2015 US$) of 1960 in South Africa to that in Uganda?
Give a very brief answer. 22.6. What is the ratio of the Taxes (in constant 2015 US$) of 1961 in South Africa to that in Uganda?
Give a very brief answer. 21.44. What is the ratio of the Taxes (in constant 2015 US$) in 1962 in South Africa to that in Uganda?
Make the answer very short. 21.01. What is the ratio of the Taxes (in constant 2015 US$) of 1963 in South Africa to that in Uganda?
Provide a succinct answer. 13.72. What is the ratio of the Taxes (in constant 2015 US$) in 1960 in Swaziland to that in Turkey?
Offer a terse response. 0.01. What is the ratio of the Taxes (in constant 2015 US$) of 1961 in Swaziland to that in Turkey?
Offer a very short reply. 0.01. What is the ratio of the Taxes (in constant 2015 US$) in 1962 in Swaziland to that in Turkey?
Offer a very short reply. 0.01. What is the ratio of the Taxes (in constant 2015 US$) in 1963 in Swaziland to that in Turkey?
Offer a very short reply. 0.01. What is the ratio of the Taxes (in constant 2015 US$) in 1960 in Swaziland to that in Uganda?
Your answer should be compact. 0.08. What is the ratio of the Taxes (in constant 2015 US$) of 1961 in Swaziland to that in Uganda?
Provide a succinct answer. 0.1. What is the ratio of the Taxes (in constant 2015 US$) of 1962 in Swaziland to that in Uganda?
Give a very brief answer. 0.09. What is the ratio of the Taxes (in constant 2015 US$) in 1963 in Swaziland to that in Uganda?
Give a very brief answer. 0.06. What is the ratio of the Taxes (in constant 2015 US$) in 1960 in Turkey to that in Uganda?
Give a very brief answer. 15.86. What is the ratio of the Taxes (in constant 2015 US$) of 1961 in Turkey to that in Uganda?
Keep it short and to the point. 9.68. What is the ratio of the Taxes (in constant 2015 US$) in 1962 in Turkey to that in Uganda?
Provide a succinct answer. 9.38. What is the ratio of the Taxes (in constant 2015 US$) of 1963 in Turkey to that in Uganda?
Your response must be concise. 6.15. What is the difference between the highest and the second highest Taxes (in constant 2015 US$) in 1960?
Provide a succinct answer. 1.13e+08. What is the difference between the highest and the second highest Taxes (in constant 2015 US$) in 1961?
Your response must be concise. 1.30e+08. What is the difference between the highest and the second highest Taxes (in constant 2015 US$) of 1962?
Your response must be concise. 1.47e+08. What is the difference between the highest and the second highest Taxes (in constant 2015 US$) of 1963?
Offer a terse response. 1.73e+08. What is the difference between the highest and the lowest Taxes (in constant 2015 US$) in 1960?
Provide a succinct answer. 3.79e+08. What is the difference between the highest and the lowest Taxes (in constant 2015 US$) of 1961?
Provide a succinct answer. 3.68e+08. What is the difference between the highest and the lowest Taxes (in constant 2015 US$) of 1962?
Your answer should be compact. 3.97e+08. What is the difference between the highest and the lowest Taxes (in constant 2015 US$) of 1963?
Give a very brief answer. 4.44e+08. 